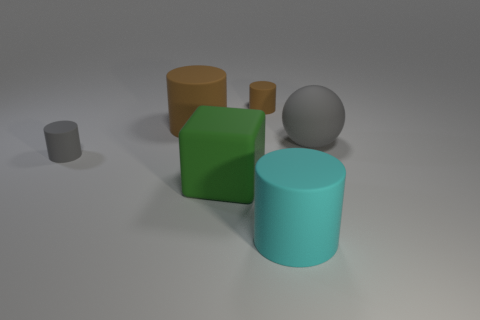Is the lighting in the scene coming from a natural source? The lighting in the scene does not appear to be from a natural source. The shadows cast by the objects are soft and diffuse, suggesting the presence of ambient artificial lighting perhaps from overhead fixtures. There is a lack of directionality and harshness that one would expect from a natural light source like the sun. 